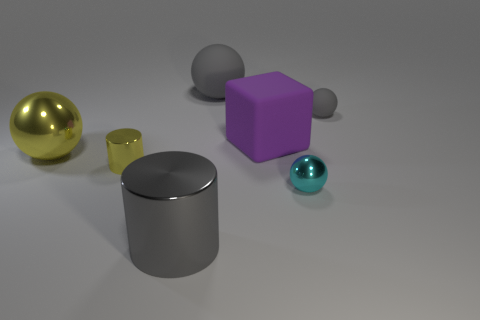Add 3 large purple objects. How many objects exist? 10 Subtract all cylinders. How many objects are left? 5 Subtract all big gray metallic things. Subtract all big metal balls. How many objects are left? 5 Add 1 large yellow metal spheres. How many large yellow metal spheres are left? 2 Add 3 green things. How many green things exist? 3 Subtract 1 cyan spheres. How many objects are left? 6 